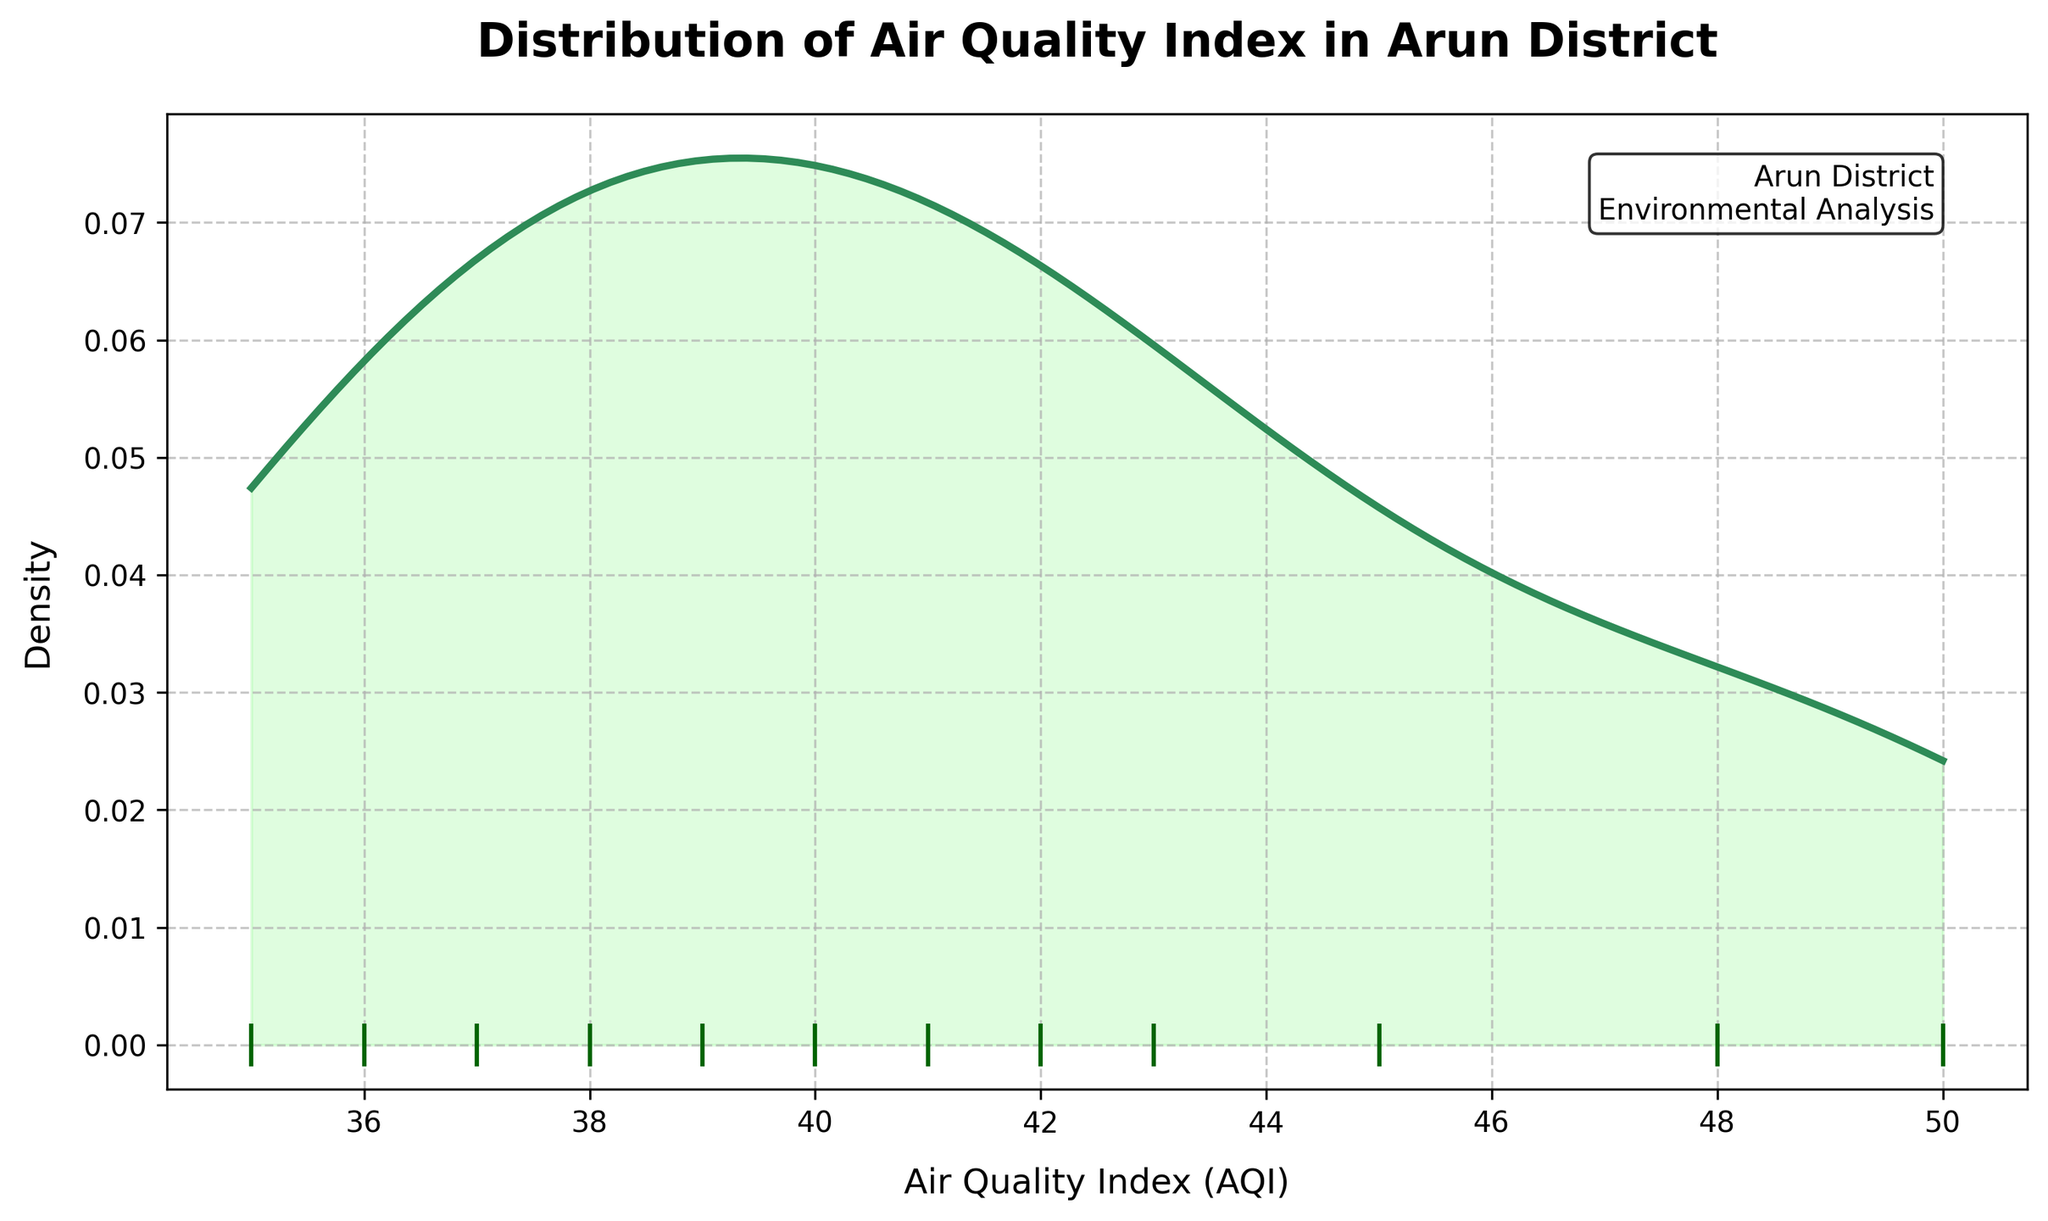What is the title of the plot? The title of the plot is located at the top and is usually larger in font size and bold compared to other text in the figure.
Answer: Distribution of Air Quality Index in Arun District How many neighborhoods are represented in the plot? Count the number of vertical lines along the x-axis, as each one represents a neighborhood in the dataset.
Answer: 12 Which neighborhood has the highest AQI value and what is it? The highest AQI value can be located by finding the rightmost rug mark on the plot. The corresponding data point is Bognor Regis with an AQI of 50.
Answer: Bognor Regis, 50 What is the range of AQI values in the plot? The range can be identified by noting the minimum and maximum values along the x-axis. The minimum AQI is 35 and the maximum is 50.
Answer: 35 to 50 Which AQI value or range appears to be the most common according to the distribution curve? The most common AQI value or range is represented by the peak of the distribution curve. The peak, or mode, seems to be around 40.
Answer: Around 40 Is the distribution of AQI values skewed? If so, in which direction? Observe the symmetry of the distribution curve. If the curve tails off more on one side, it is skewed in that direction. The distribution appears slightly left-skewed as it tails off more on the lower AQI side.
Answer: Slightly left-skewed What is the approximate density value at an AQI of 45? Look at the y-axis value that corresponds to the height of the distribution curve over an AQI of 45. It seems to be around 0.05.
Answer: Approximately 0.05 Which neighborhood has the lowest AQI value and what is it? The lowest AQI value can be located by finding the leftmost rug mark on the plot. The corresponding data point is Rustington with an AQI of 35.
Answer: Rustington, 35 What is the average AQI value across the neighborhoods? Average can be calculated by summing the AQI values of all neighborhoods and dividing by the number of neighborhoods: (42 + 35 + 40 + 38 + 45 + 48 + 50 + 43 + 37 + 39 + 36 + 41) / 12 = 40.25.
Answer: 40.25 